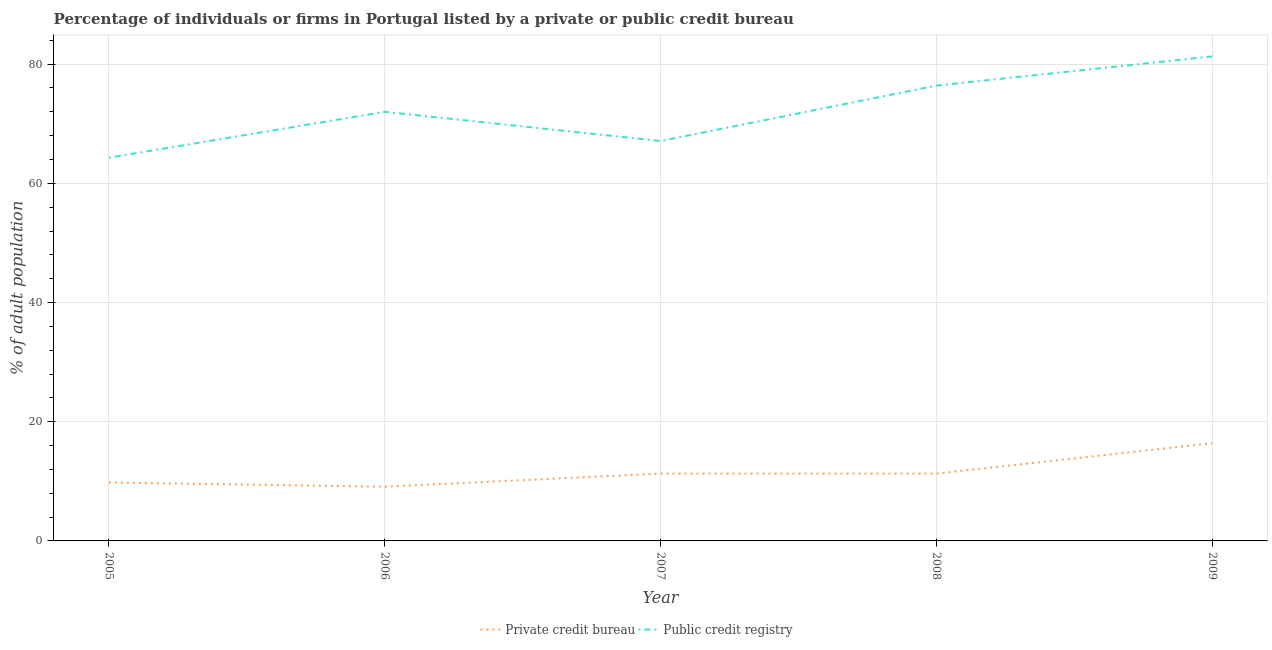Is the number of lines equal to the number of legend labels?
Ensure brevity in your answer.  Yes. What is the percentage of firms listed by public credit bureau in 2009?
Your answer should be compact. 81.3. Across all years, what is the maximum percentage of firms listed by public credit bureau?
Your answer should be compact. 81.3. Across all years, what is the minimum percentage of firms listed by private credit bureau?
Provide a short and direct response. 9.1. In which year was the percentage of firms listed by public credit bureau minimum?
Give a very brief answer. 2005. What is the total percentage of firms listed by private credit bureau in the graph?
Your response must be concise. 57.9. What is the difference between the percentage of firms listed by public credit bureau in 2009 and the percentage of firms listed by private credit bureau in 2006?
Provide a succinct answer. 72.2. What is the average percentage of firms listed by public credit bureau per year?
Provide a succinct answer. 72.22. In the year 2008, what is the difference between the percentage of firms listed by private credit bureau and percentage of firms listed by public credit bureau?
Offer a very short reply. -65.1. What is the ratio of the percentage of firms listed by public credit bureau in 2005 to that in 2008?
Keep it short and to the point. 0.84. Is the difference between the percentage of firms listed by public credit bureau in 2007 and 2009 greater than the difference between the percentage of firms listed by private credit bureau in 2007 and 2009?
Offer a terse response. No. What is the difference between the highest and the second highest percentage of firms listed by public credit bureau?
Provide a succinct answer. 4.9. What is the difference between the highest and the lowest percentage of firms listed by private credit bureau?
Your response must be concise. 7.3. In how many years, is the percentage of firms listed by public credit bureau greater than the average percentage of firms listed by public credit bureau taken over all years?
Your answer should be very brief. 2. Is the sum of the percentage of firms listed by private credit bureau in 2008 and 2009 greater than the maximum percentage of firms listed by public credit bureau across all years?
Your response must be concise. No. Is the percentage of firms listed by public credit bureau strictly less than the percentage of firms listed by private credit bureau over the years?
Offer a very short reply. No. Does the graph contain any zero values?
Offer a terse response. No. Does the graph contain grids?
Your response must be concise. Yes. Where does the legend appear in the graph?
Provide a succinct answer. Bottom center. How many legend labels are there?
Ensure brevity in your answer.  2. What is the title of the graph?
Keep it short and to the point. Percentage of individuals or firms in Portugal listed by a private or public credit bureau. Does "Subsidies" appear as one of the legend labels in the graph?
Offer a very short reply. No. What is the label or title of the X-axis?
Give a very brief answer. Year. What is the label or title of the Y-axis?
Make the answer very short. % of adult population. What is the % of adult population in Private credit bureau in 2005?
Offer a very short reply. 9.8. What is the % of adult population in Public credit registry in 2005?
Make the answer very short. 64.3. What is the % of adult population of Private credit bureau in 2006?
Keep it short and to the point. 9.1. What is the % of adult population of Public credit registry in 2007?
Offer a terse response. 67.1. What is the % of adult population in Public credit registry in 2008?
Provide a short and direct response. 76.4. What is the % of adult population in Private credit bureau in 2009?
Keep it short and to the point. 16.4. What is the % of adult population of Public credit registry in 2009?
Make the answer very short. 81.3. Across all years, what is the maximum % of adult population in Private credit bureau?
Give a very brief answer. 16.4. Across all years, what is the maximum % of adult population of Public credit registry?
Give a very brief answer. 81.3. Across all years, what is the minimum % of adult population in Private credit bureau?
Offer a very short reply. 9.1. Across all years, what is the minimum % of adult population in Public credit registry?
Offer a very short reply. 64.3. What is the total % of adult population of Private credit bureau in the graph?
Ensure brevity in your answer.  57.9. What is the total % of adult population in Public credit registry in the graph?
Your answer should be very brief. 361.1. What is the difference between the % of adult population of Private credit bureau in 2005 and that in 2007?
Offer a very short reply. -1.5. What is the difference between the % of adult population in Public credit registry in 2005 and that in 2007?
Your response must be concise. -2.8. What is the difference between the % of adult population in Private credit bureau in 2005 and that in 2008?
Make the answer very short. -1.5. What is the difference between the % of adult population of Private credit bureau in 2005 and that in 2009?
Offer a terse response. -6.6. What is the difference between the % of adult population in Public credit registry in 2006 and that in 2007?
Your answer should be compact. 4.9. What is the difference between the % of adult population of Private credit bureau in 2006 and that in 2008?
Your response must be concise. -2.2. What is the difference between the % of adult population in Private credit bureau in 2006 and that in 2009?
Provide a short and direct response. -7.3. What is the difference between the % of adult population of Public credit registry in 2006 and that in 2009?
Your response must be concise. -9.3. What is the difference between the % of adult population of Public credit registry in 2007 and that in 2008?
Make the answer very short. -9.3. What is the difference between the % of adult population in Public credit registry in 2007 and that in 2009?
Give a very brief answer. -14.2. What is the difference between the % of adult population of Public credit registry in 2008 and that in 2009?
Give a very brief answer. -4.9. What is the difference between the % of adult population of Private credit bureau in 2005 and the % of adult population of Public credit registry in 2006?
Ensure brevity in your answer.  -62.2. What is the difference between the % of adult population in Private credit bureau in 2005 and the % of adult population in Public credit registry in 2007?
Ensure brevity in your answer.  -57.3. What is the difference between the % of adult population in Private credit bureau in 2005 and the % of adult population in Public credit registry in 2008?
Your response must be concise. -66.6. What is the difference between the % of adult population of Private credit bureau in 2005 and the % of adult population of Public credit registry in 2009?
Offer a very short reply. -71.5. What is the difference between the % of adult population of Private credit bureau in 2006 and the % of adult population of Public credit registry in 2007?
Make the answer very short. -58. What is the difference between the % of adult population in Private credit bureau in 2006 and the % of adult population in Public credit registry in 2008?
Ensure brevity in your answer.  -67.3. What is the difference between the % of adult population in Private credit bureau in 2006 and the % of adult population in Public credit registry in 2009?
Your answer should be compact. -72.2. What is the difference between the % of adult population of Private credit bureau in 2007 and the % of adult population of Public credit registry in 2008?
Your response must be concise. -65.1. What is the difference between the % of adult population in Private credit bureau in 2007 and the % of adult population in Public credit registry in 2009?
Your answer should be compact. -70. What is the difference between the % of adult population of Private credit bureau in 2008 and the % of adult population of Public credit registry in 2009?
Provide a succinct answer. -70. What is the average % of adult population in Private credit bureau per year?
Make the answer very short. 11.58. What is the average % of adult population of Public credit registry per year?
Offer a very short reply. 72.22. In the year 2005, what is the difference between the % of adult population in Private credit bureau and % of adult population in Public credit registry?
Offer a very short reply. -54.5. In the year 2006, what is the difference between the % of adult population of Private credit bureau and % of adult population of Public credit registry?
Offer a terse response. -62.9. In the year 2007, what is the difference between the % of adult population of Private credit bureau and % of adult population of Public credit registry?
Provide a short and direct response. -55.8. In the year 2008, what is the difference between the % of adult population of Private credit bureau and % of adult population of Public credit registry?
Give a very brief answer. -65.1. In the year 2009, what is the difference between the % of adult population in Private credit bureau and % of adult population in Public credit registry?
Provide a short and direct response. -64.9. What is the ratio of the % of adult population in Public credit registry in 2005 to that in 2006?
Give a very brief answer. 0.89. What is the ratio of the % of adult population in Private credit bureau in 2005 to that in 2007?
Your response must be concise. 0.87. What is the ratio of the % of adult population in Public credit registry in 2005 to that in 2007?
Your answer should be compact. 0.96. What is the ratio of the % of adult population in Private credit bureau in 2005 to that in 2008?
Give a very brief answer. 0.87. What is the ratio of the % of adult population of Public credit registry in 2005 to that in 2008?
Offer a terse response. 0.84. What is the ratio of the % of adult population of Private credit bureau in 2005 to that in 2009?
Your answer should be compact. 0.6. What is the ratio of the % of adult population in Public credit registry in 2005 to that in 2009?
Offer a very short reply. 0.79. What is the ratio of the % of adult population of Private credit bureau in 2006 to that in 2007?
Ensure brevity in your answer.  0.81. What is the ratio of the % of adult population in Public credit registry in 2006 to that in 2007?
Provide a short and direct response. 1.07. What is the ratio of the % of adult population in Private credit bureau in 2006 to that in 2008?
Give a very brief answer. 0.81. What is the ratio of the % of adult population in Public credit registry in 2006 to that in 2008?
Provide a succinct answer. 0.94. What is the ratio of the % of adult population in Private credit bureau in 2006 to that in 2009?
Your answer should be compact. 0.55. What is the ratio of the % of adult population in Public credit registry in 2006 to that in 2009?
Your answer should be very brief. 0.89. What is the ratio of the % of adult population of Public credit registry in 2007 to that in 2008?
Your response must be concise. 0.88. What is the ratio of the % of adult population in Private credit bureau in 2007 to that in 2009?
Offer a terse response. 0.69. What is the ratio of the % of adult population of Public credit registry in 2007 to that in 2009?
Your answer should be very brief. 0.83. What is the ratio of the % of adult population in Private credit bureau in 2008 to that in 2009?
Provide a succinct answer. 0.69. What is the ratio of the % of adult population in Public credit registry in 2008 to that in 2009?
Your response must be concise. 0.94. What is the difference between the highest and the lowest % of adult population of Private credit bureau?
Your answer should be compact. 7.3. What is the difference between the highest and the lowest % of adult population in Public credit registry?
Keep it short and to the point. 17. 